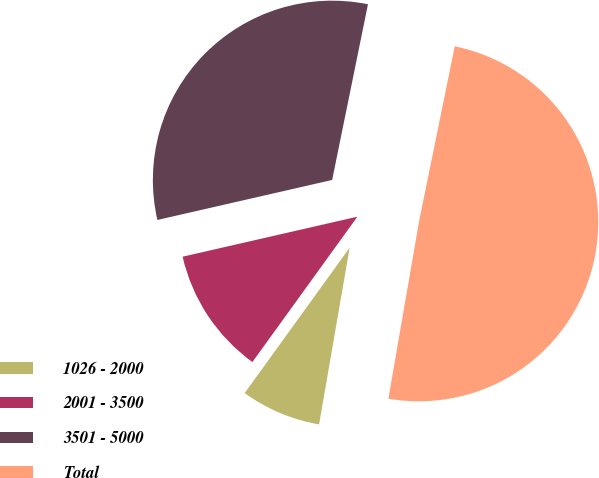Convert chart to OTSL. <chart><loc_0><loc_0><loc_500><loc_500><pie_chart><fcel>1026 - 2000<fcel>2001 - 3500<fcel>3501 - 5000<fcel>Total<nl><fcel>7.23%<fcel>11.46%<fcel>31.78%<fcel>49.52%<nl></chart> 